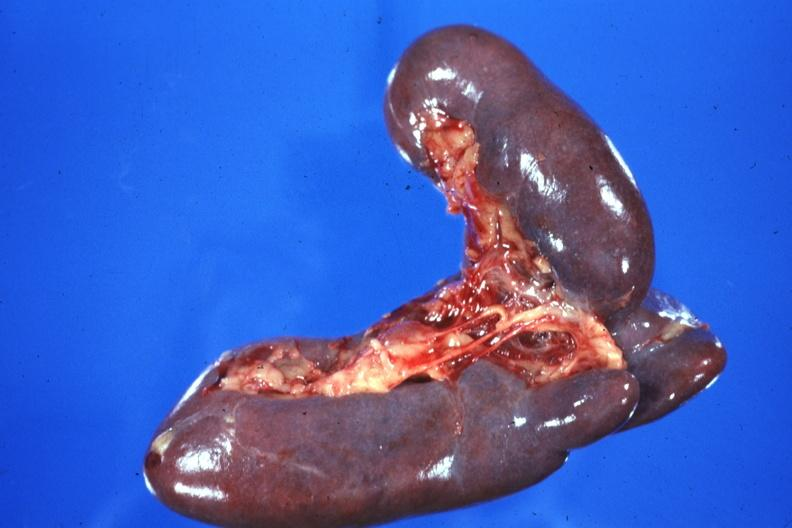s bilobed present?
Answer the question using a single word or phrase. Yes 